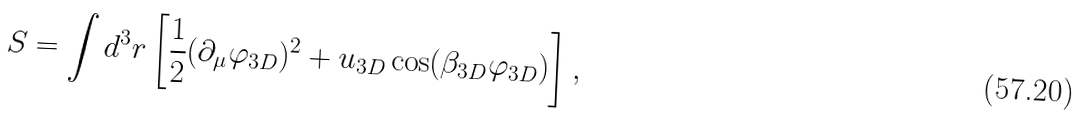<formula> <loc_0><loc_0><loc_500><loc_500>S = \int d ^ { 3 } r \left [ { \frac { 1 } { 2 } } ( \partial _ { \mu } \varphi _ { 3 D } ) ^ { 2 } + u _ { 3 D } \cos ( \beta _ { 3 D } \varphi _ { 3 D } ) \right ] ,</formula> 